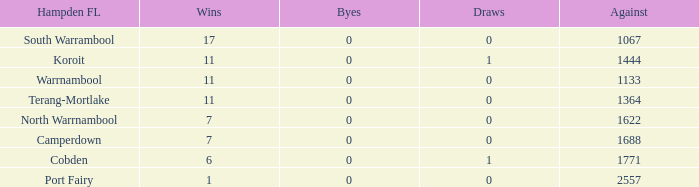Parse the table in full. {'header': ['Hampden FL', 'Wins', 'Byes', 'Draws', 'Against'], 'rows': [['South Warrambool', '17', '0', '0', '1067'], ['Koroit', '11', '0', '1', '1444'], ['Warrnambool', '11', '0', '0', '1133'], ['Terang-Mortlake', '11', '0', '0', '1364'], ['North Warrnambool', '7', '0', '0', '1622'], ['Camperdown', '7', '0', '0', '1688'], ['Cobden', '6', '0', '1', '1771'], ['Port Fairy', '1', '0', '0', '2557']]} What were the losses when the byes were less than 0? None. 